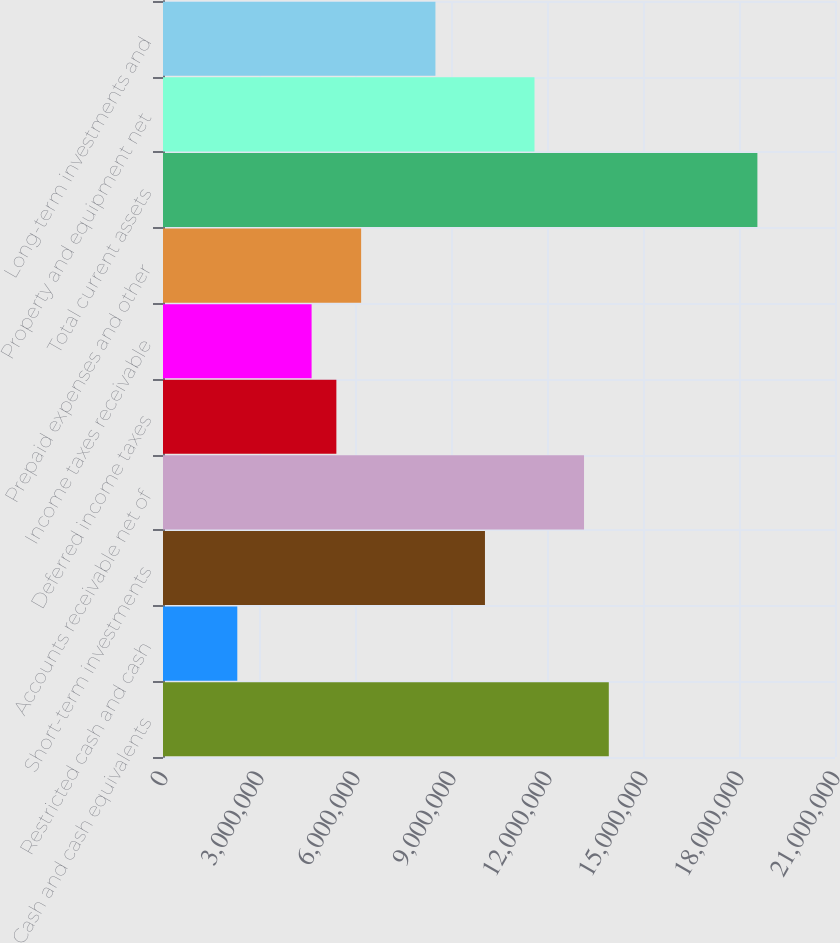<chart> <loc_0><loc_0><loc_500><loc_500><bar_chart><fcel>Cash and cash equivalents<fcel>Restricted cash and cash<fcel>Short-term investments<fcel>Accounts receivable net of<fcel>Deferred income taxes<fcel>Income taxes receivable<fcel>Prepaid expenses and other<fcel>Total current assets<fcel>Property and equipment net<fcel>Long-term investments and<nl><fcel>1.39311e+07<fcel>2.32184e+06<fcel>1.00613e+07<fcel>1.31571e+07<fcel>5.41764e+06<fcel>4.64369e+06<fcel>6.19158e+06<fcel>1.85748e+07<fcel>1.16092e+07<fcel>8.51343e+06<nl></chart> 